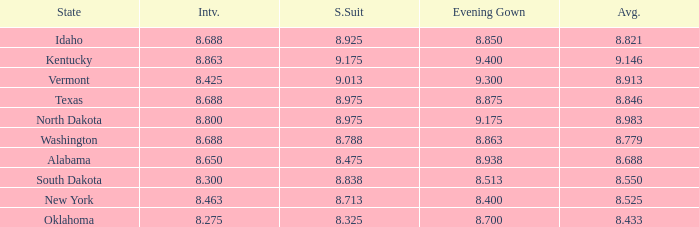Who had the lowest interview score from South Dakota with an evening gown less than 8.513? None. Help me parse the entirety of this table. {'header': ['State', 'Intv.', 'S.Suit', 'Evening Gown', 'Avg.'], 'rows': [['Idaho', '8.688', '8.925', '8.850', '8.821'], ['Kentucky', '8.863', '9.175', '9.400', '9.146'], ['Vermont', '8.425', '9.013', '9.300', '8.913'], ['Texas', '8.688', '8.975', '8.875', '8.846'], ['North Dakota', '8.800', '8.975', '9.175', '8.983'], ['Washington', '8.688', '8.788', '8.863', '8.779'], ['Alabama', '8.650', '8.475', '8.938', '8.688'], ['South Dakota', '8.300', '8.838', '8.513', '8.550'], ['New York', '8.463', '8.713', '8.400', '8.525'], ['Oklahoma', '8.275', '8.325', '8.700', '8.433']]} 